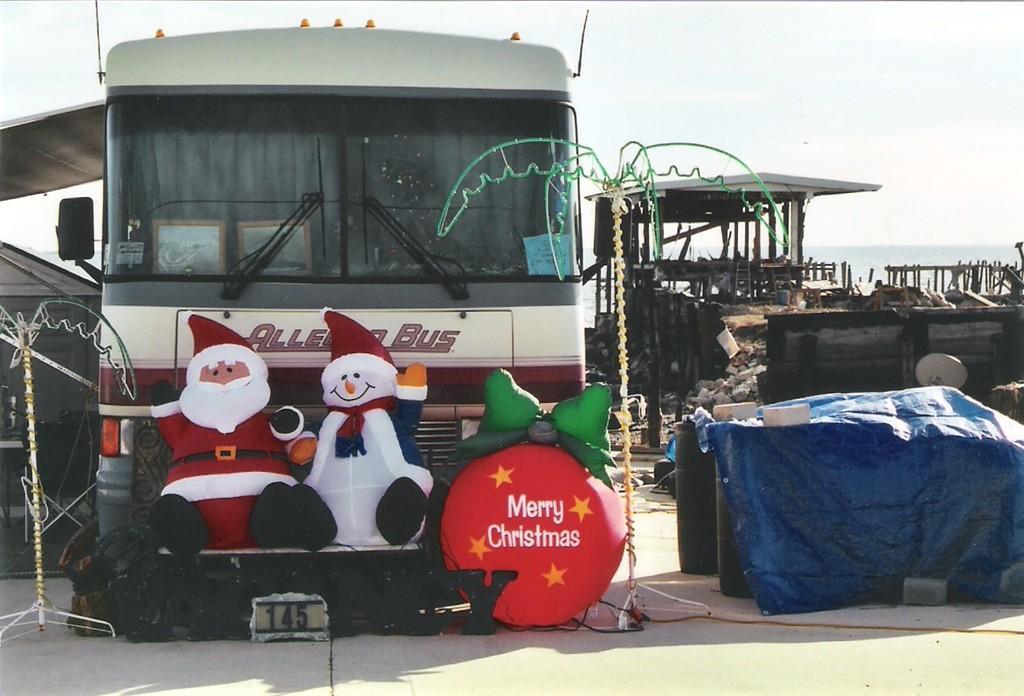Describe this image in one or two sentences. In this image there is a bus. Before it there are few toys and a balloon are there. Left side there is a stand. Right side there are few drums covered with a cover. Behind there is some construction of a house. Before it there is a fence. Left side there is a tent. Top of the image there is sky. 